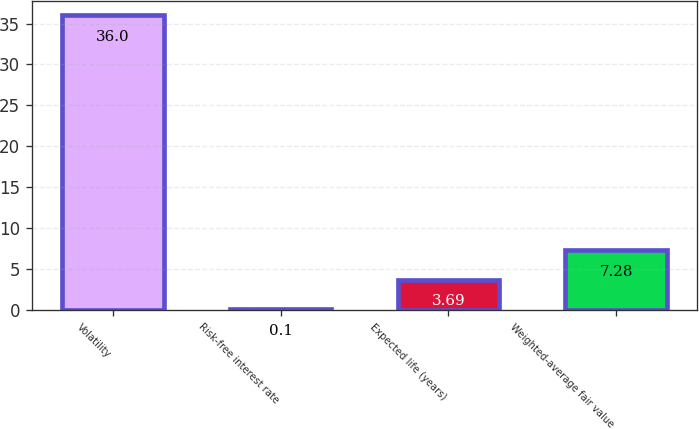Convert chart to OTSL. <chart><loc_0><loc_0><loc_500><loc_500><bar_chart><fcel>Volatility<fcel>Risk-free interest rate<fcel>Expected life (years)<fcel>Weighted-average fair value<nl><fcel>36<fcel>0.1<fcel>3.69<fcel>7.28<nl></chart> 